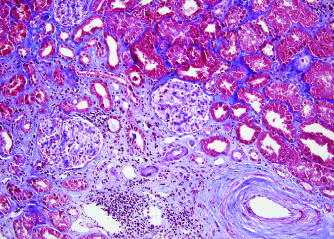what do interstitial fibrosis and tubular atrophy result from?
Answer the question using a single word or phrase. Arteriosclerosis of arteries and arterioles in a chronically rejecting kidney allograft 